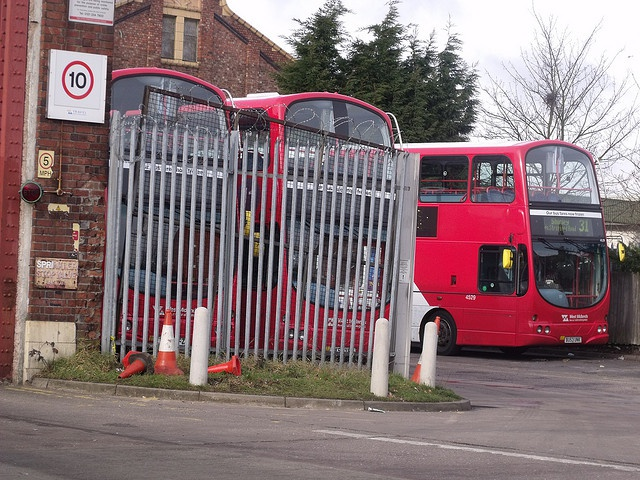Describe the objects in this image and their specific colors. I can see bus in brown, black, and gray tones, bus in brown, darkgray, gray, black, and maroon tones, bus in brown, darkgray, gray, black, and maroon tones, bus in brown, gray, black, darkgray, and maroon tones, and traffic light in brown, black, gray, and maroon tones in this image. 